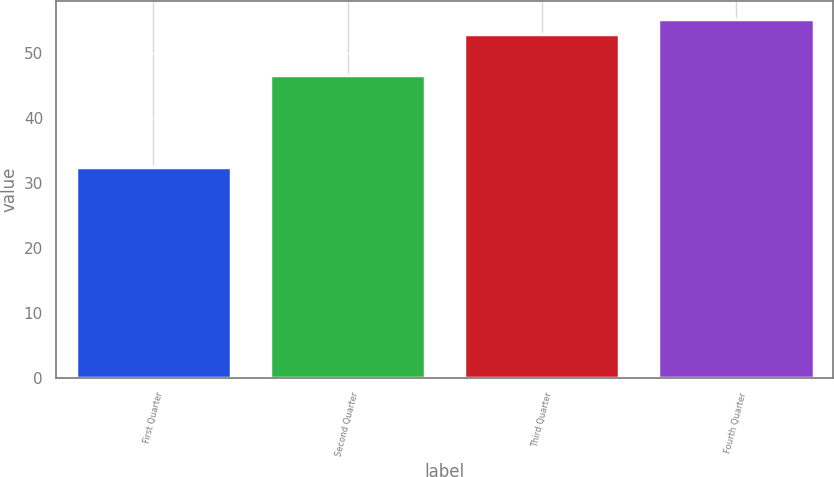Convert chart to OTSL. <chart><loc_0><loc_0><loc_500><loc_500><bar_chart><fcel>First Quarter<fcel>Second Quarter<fcel>Third Quarter<fcel>Fourth Quarter<nl><fcel>32.46<fcel>46.72<fcel>53.06<fcel>55.28<nl></chart> 